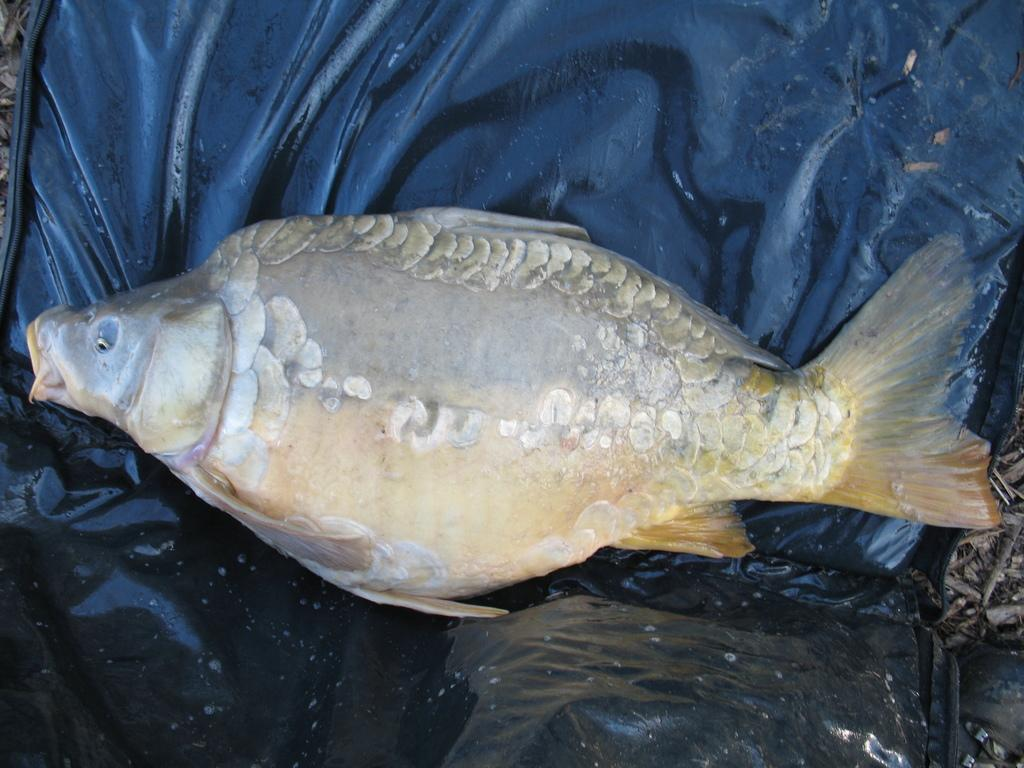What is the main subject of the image? The main subject of the image is a fish. What is the fish placed on? The fish is on a black cover. What type of popcorn is being served in the image? There is no popcorn present in the image; it features a fish on a black cover. What time is displayed on the watch in the image? There is no watch present in the image. 